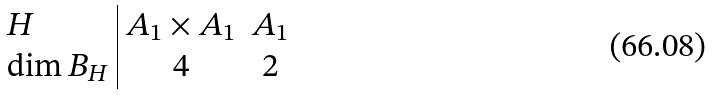Convert formula to latex. <formula><loc_0><loc_0><loc_500><loc_500>\begin{array} { l | c c } H & A _ { 1 } \times A _ { 1 } & A _ { 1 } \\ \dim B _ { H } & 4 & 2 \end{array}</formula> 